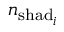Convert formula to latex. <formula><loc_0><loc_0><loc_500><loc_500>n _ { s h a d _ { i } }</formula> 